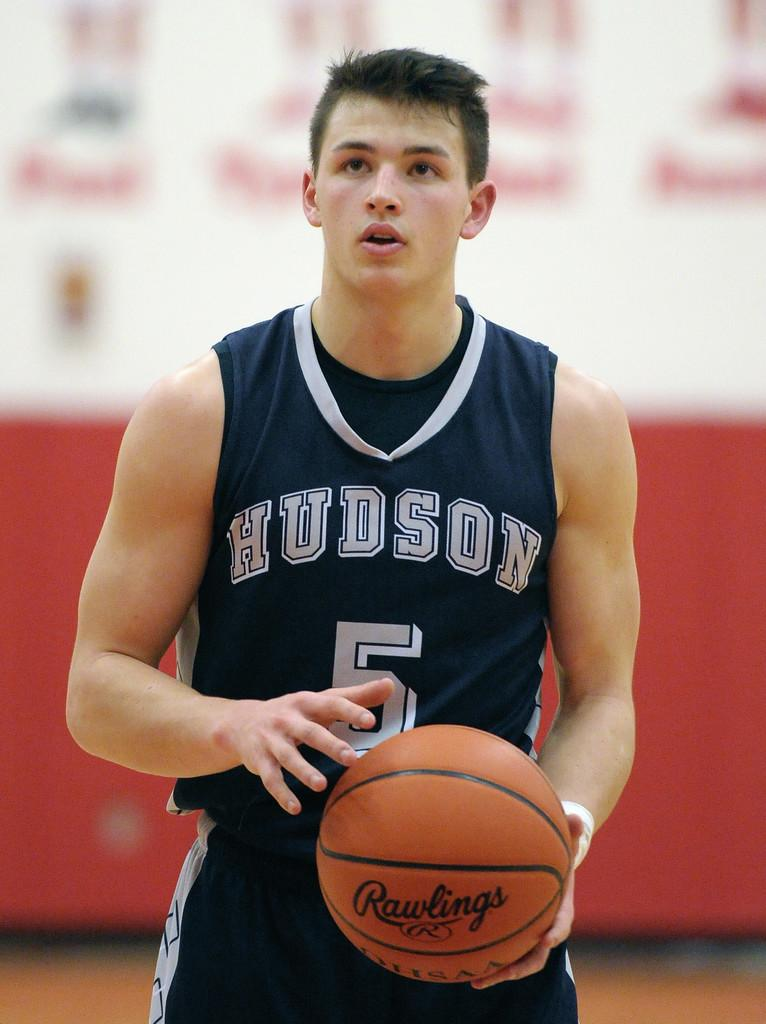<image>
Write a terse but informative summary of the picture. Man wearing a basketball jersey that says HUDSON on it. 